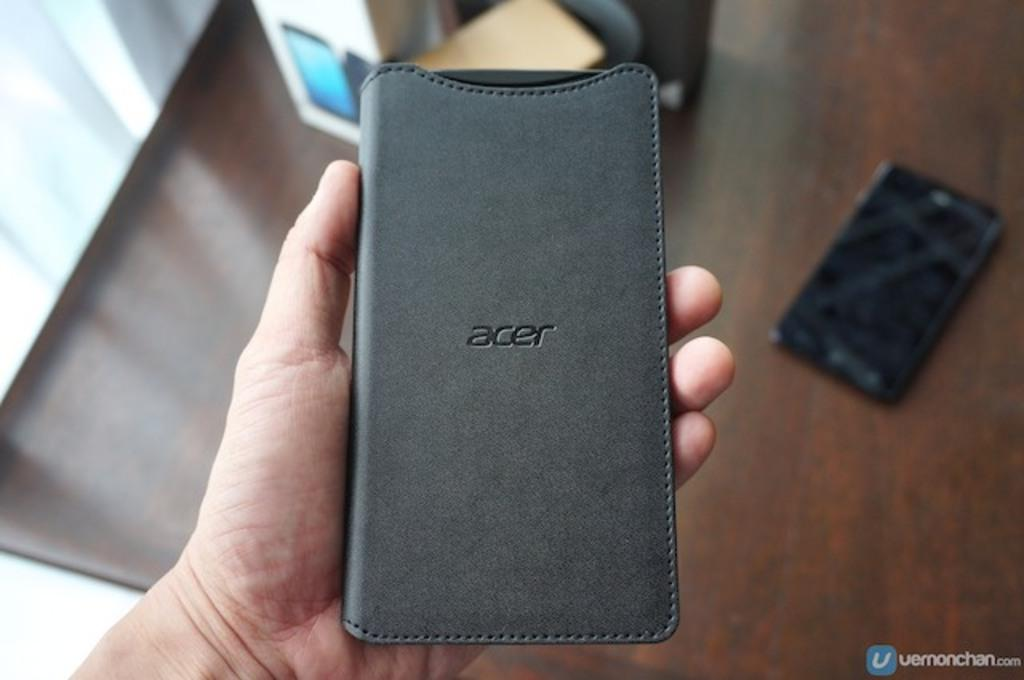<image>
Provide a brief description of the given image. A black Acer phone case with a broken phone in the background. 